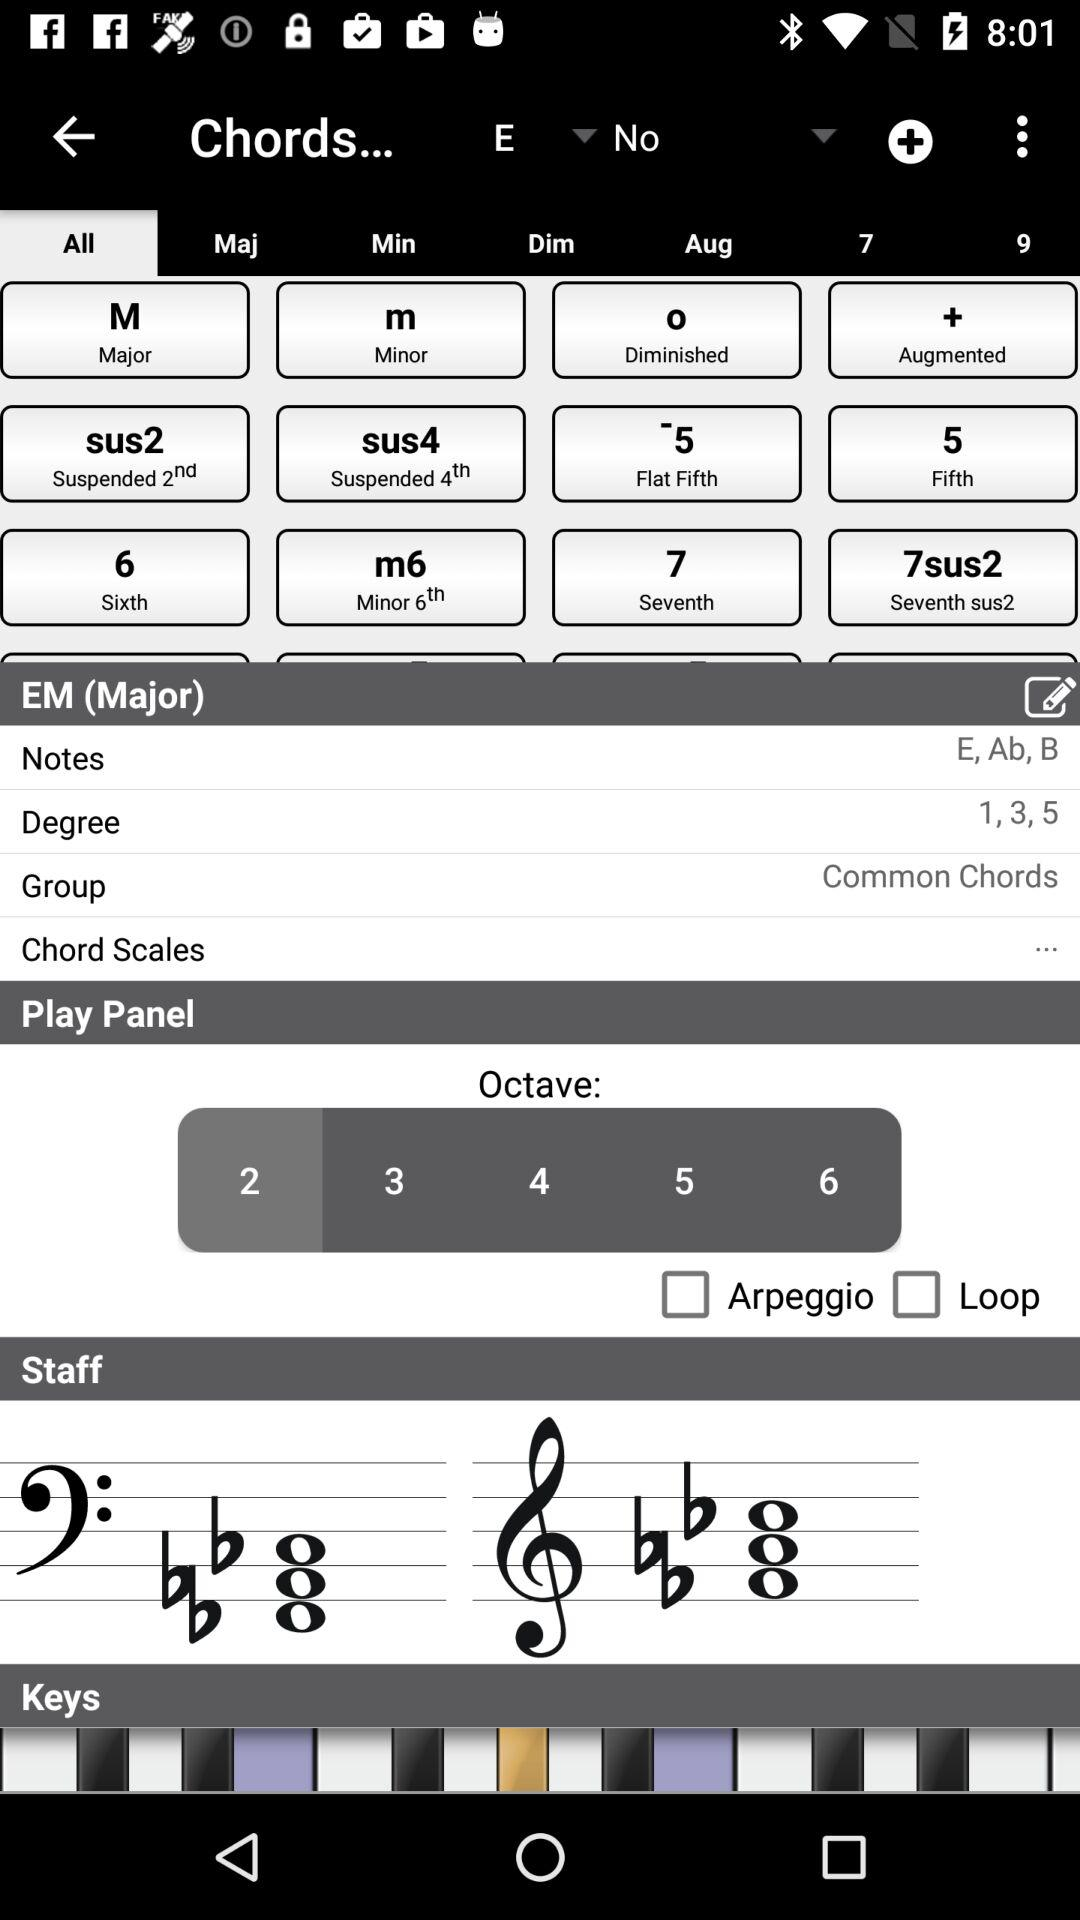What are the notes of EM (Major)? The notes of EM (Major) are E, Ab and B. 